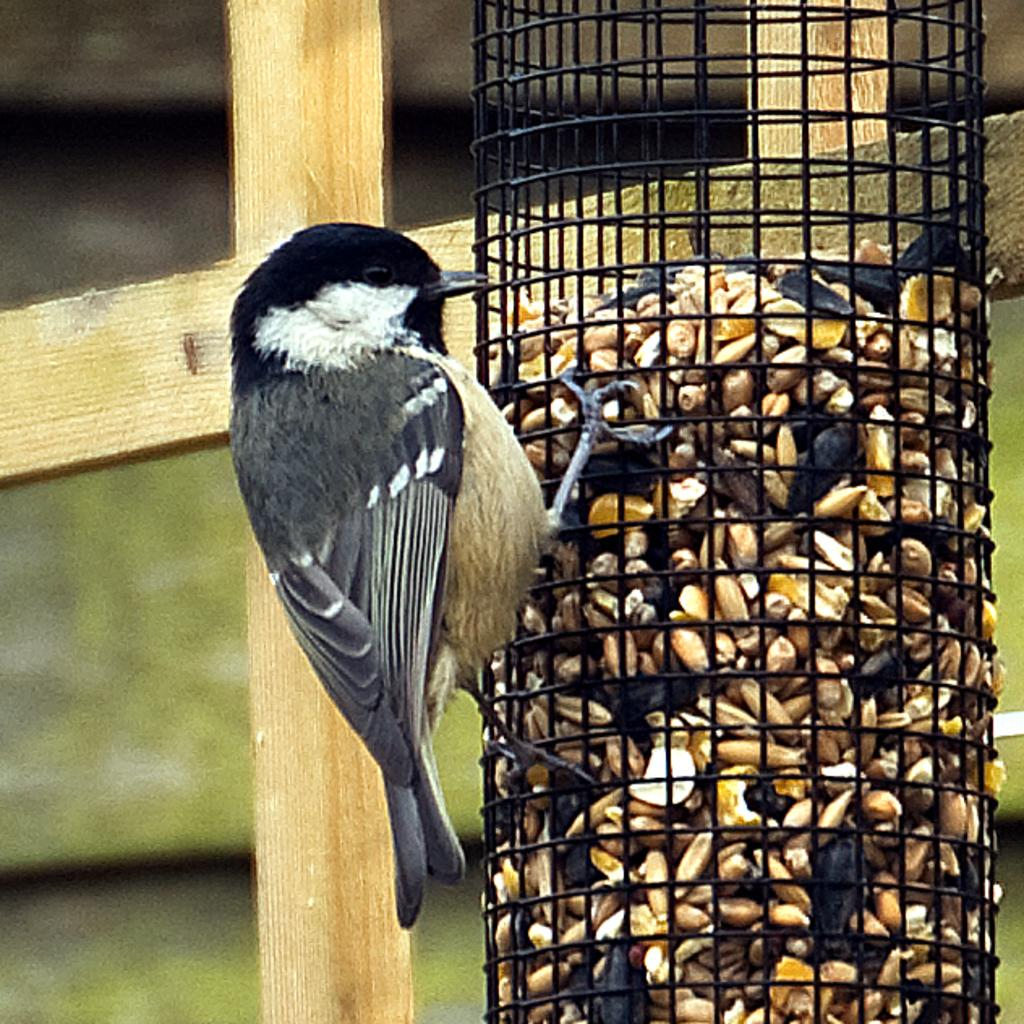What is inside the cage in the image? There are seeds in the cage in the image. What can be seen in the background of the image? There is a fence and a bird visible in the background of the image. How does the bird contribute to pollution in the image? There is no indication of pollution in the image, and the bird's presence does not contribute to any pollution. 